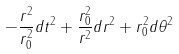<formula> <loc_0><loc_0><loc_500><loc_500>- \frac { r ^ { 2 } } { r _ { 0 } ^ { 2 } } d t ^ { 2 } + \frac { r _ { 0 } ^ { 2 } } { r ^ { 2 } } d r ^ { 2 } + r _ { 0 } ^ { 2 } d \theta ^ { 2 }</formula> 